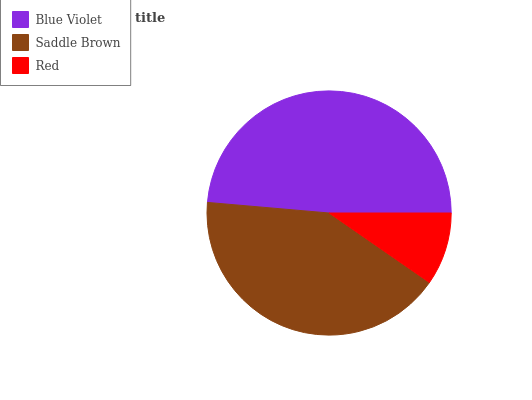Is Red the minimum?
Answer yes or no. Yes. Is Blue Violet the maximum?
Answer yes or no. Yes. Is Saddle Brown the minimum?
Answer yes or no. No. Is Saddle Brown the maximum?
Answer yes or no. No. Is Blue Violet greater than Saddle Brown?
Answer yes or no. Yes. Is Saddle Brown less than Blue Violet?
Answer yes or no. Yes. Is Saddle Brown greater than Blue Violet?
Answer yes or no. No. Is Blue Violet less than Saddle Brown?
Answer yes or no. No. Is Saddle Brown the high median?
Answer yes or no. Yes. Is Saddle Brown the low median?
Answer yes or no. Yes. Is Blue Violet the high median?
Answer yes or no. No. Is Blue Violet the low median?
Answer yes or no. No. 